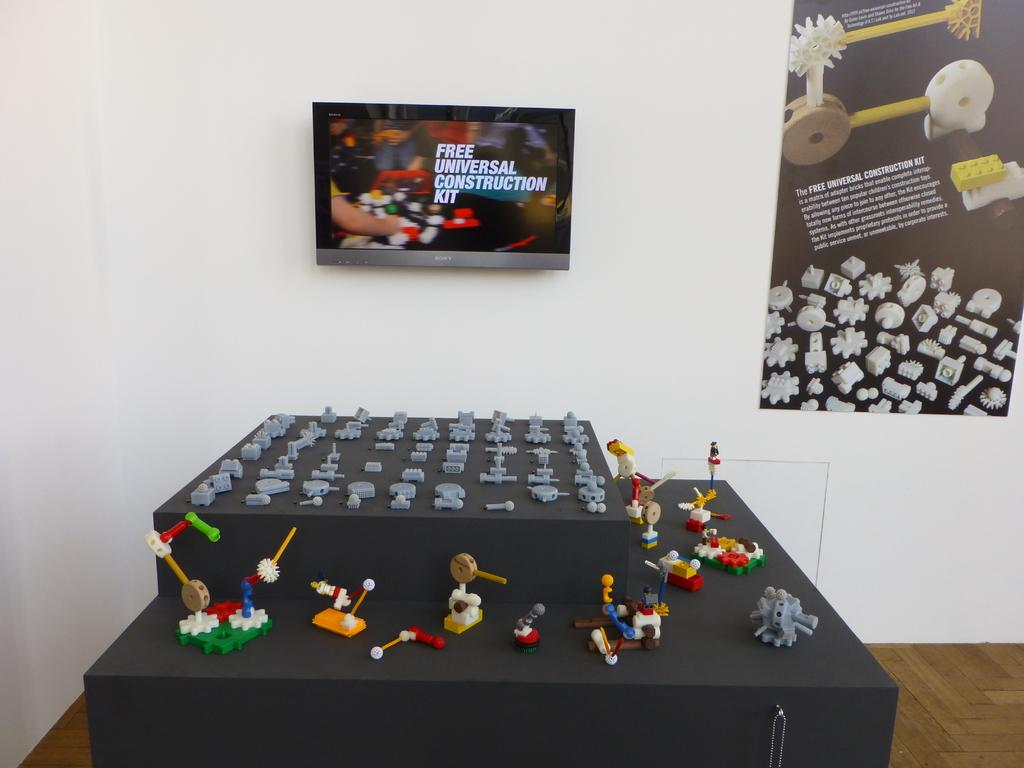<image>
Present a compact description of the photo's key features. An exhibit of a free universal construction kit display. 